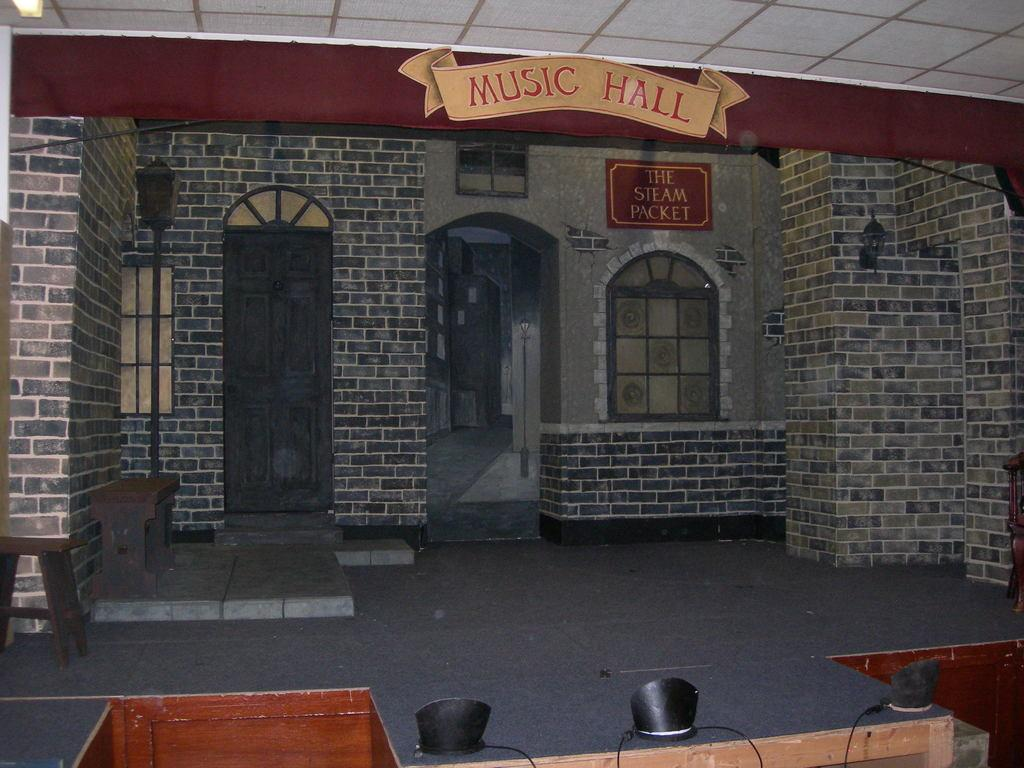What is the main structure in the center of the image? There is a music hall in the center of the image. What type of seating is available on the left side of the image? There are benches on the left side of the image. How much profit does the music hall generate in the image? There is no information about the profit generated by the music hall in the image. How many girls are present in the image? There is no information about the presence of girls in the image. 